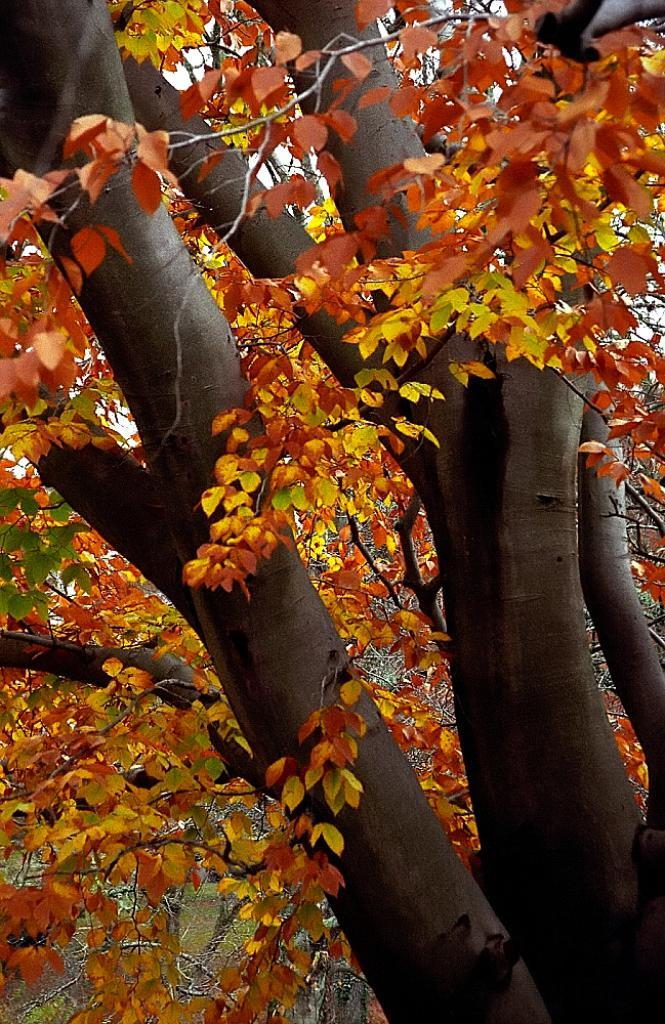What is present in the image? There is a tree in the image. What can be observed about the tree? There are leaves on the tree. What type of collar can be seen on the tree in the image? There is no collar present on the tree in the image. What question is being asked by the tree in the image? Trees do not have the ability to ask questions, so there is no question being asked by the tree in the image. 